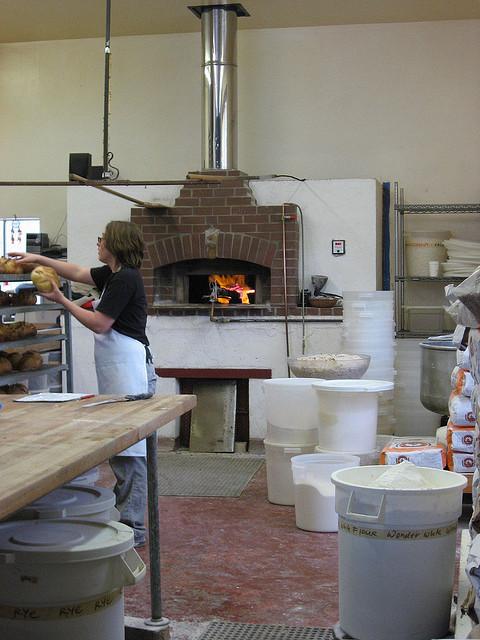Is this a pizza oven?
Concise answer only. Yes. How many people are in this room?
Quick response, please. 1. Will the dough rise properly?
Write a very short answer. Yes. 